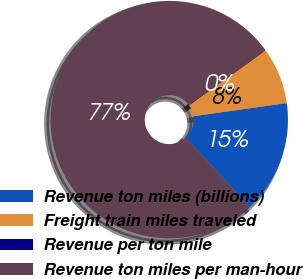Convert chart. <chart><loc_0><loc_0><loc_500><loc_500><pie_chart><fcel>Revenue ton miles (billions)<fcel>Freight train miles traveled<fcel>Revenue per ton mile<fcel>Revenue ton miles per man-hour<nl><fcel>15.39%<fcel>7.69%<fcel>0.0%<fcel>76.92%<nl></chart> 